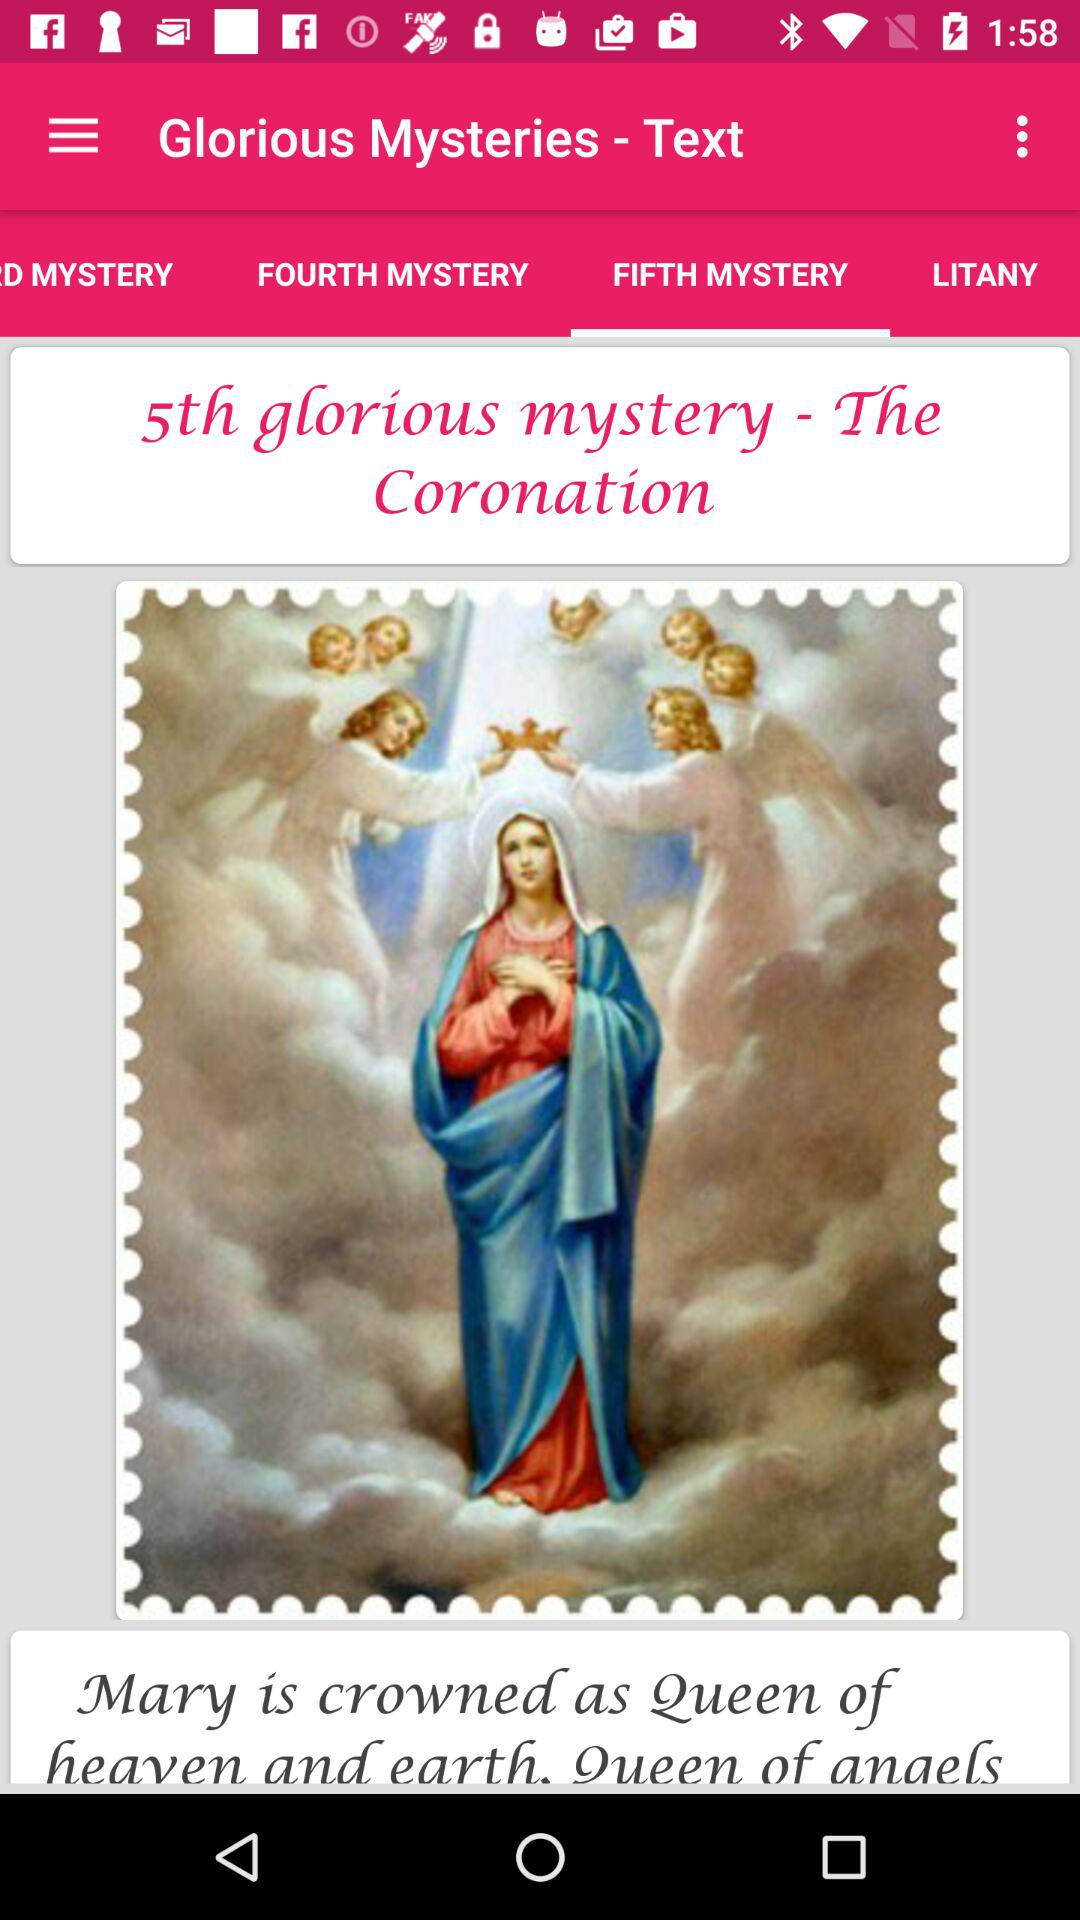How many mysteries are there in total?
Answer the question using a single word or phrase. 5 